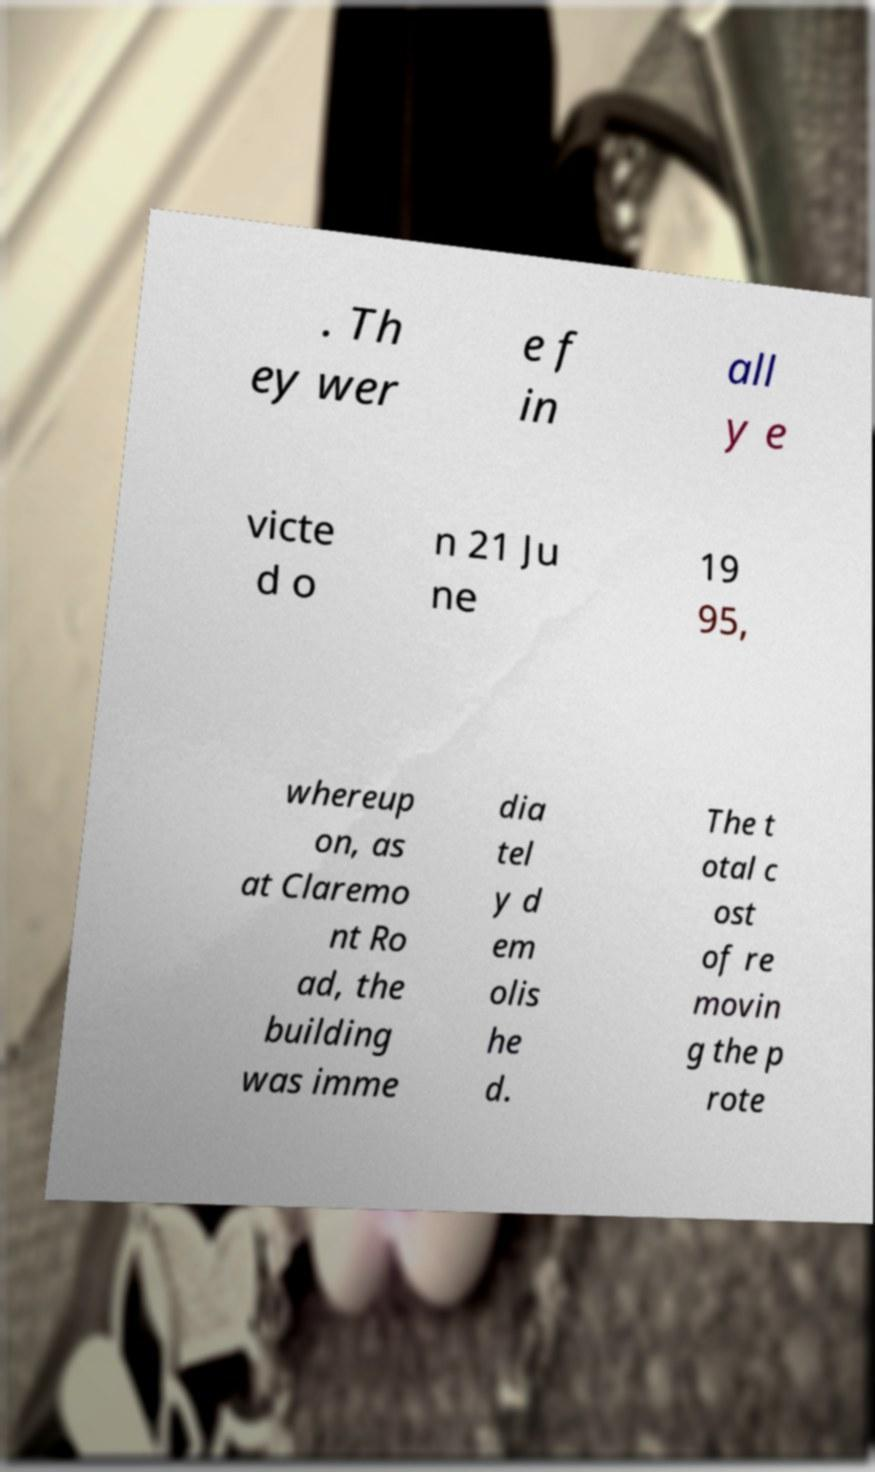Can you read and provide the text displayed in the image?This photo seems to have some interesting text. Can you extract and type it out for me? . Th ey wer e f in all y e victe d o n 21 Ju ne 19 95, whereup on, as at Claremo nt Ro ad, the building was imme dia tel y d em olis he d. The t otal c ost of re movin g the p rote 